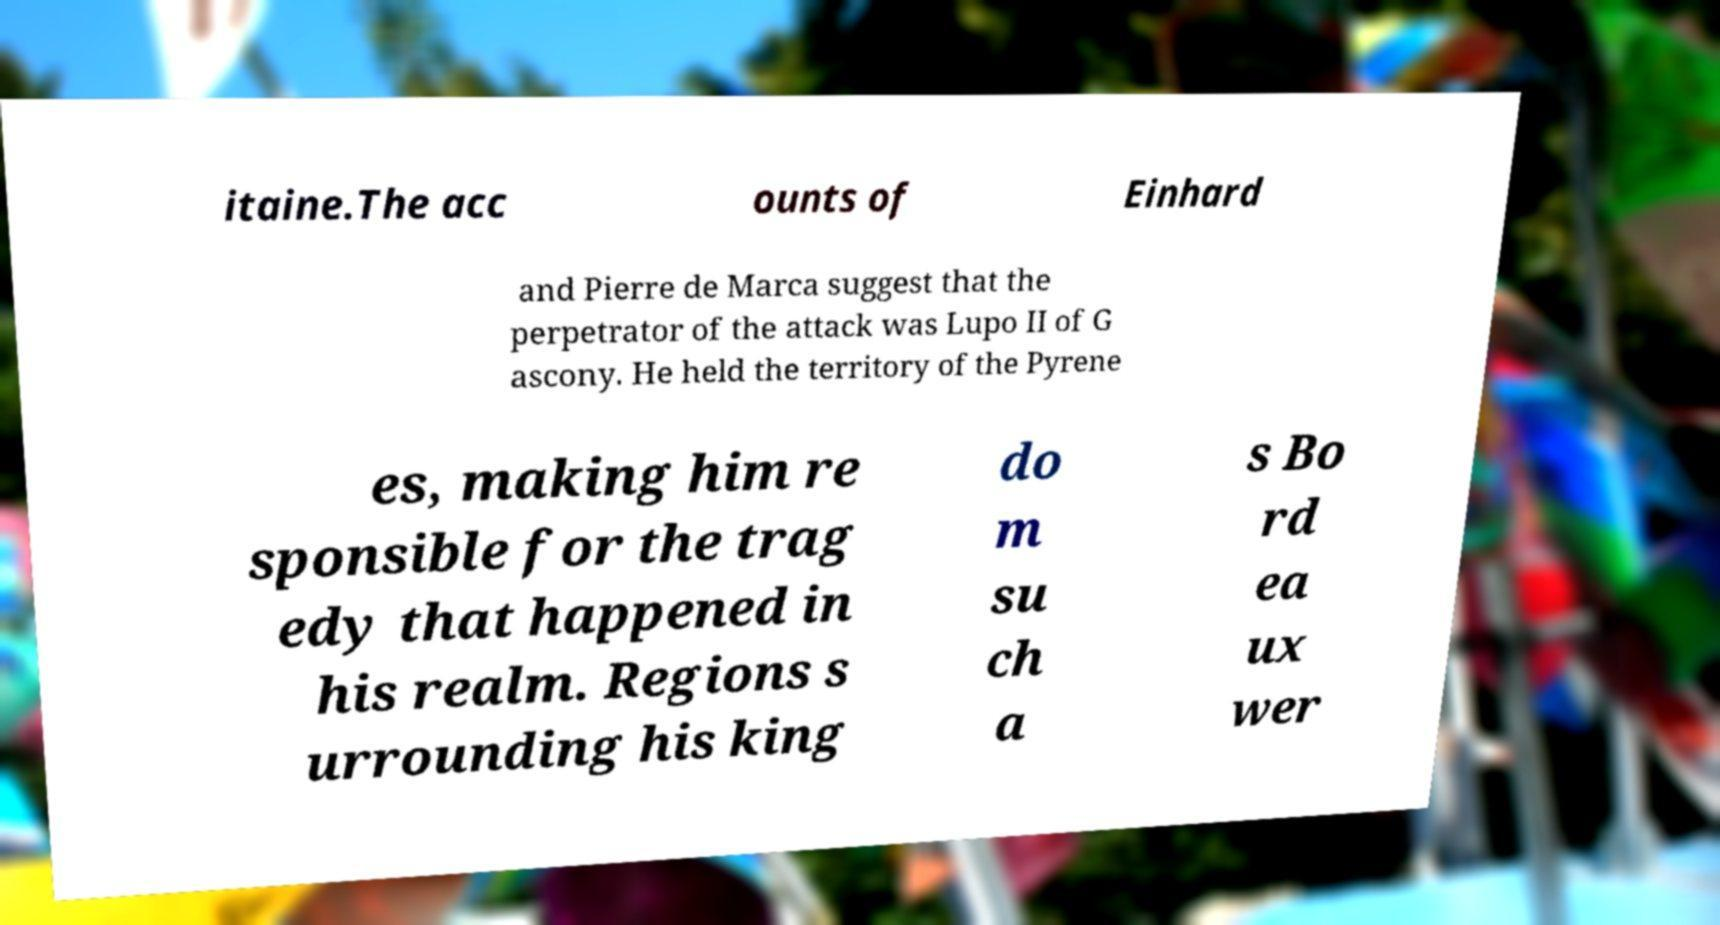What messages or text are displayed in this image? I need them in a readable, typed format. itaine.The acc ounts of Einhard and Pierre de Marca suggest that the perpetrator of the attack was Lupo II of G ascony. He held the territory of the Pyrene es, making him re sponsible for the trag edy that happened in his realm. Regions s urrounding his king do m su ch a s Bo rd ea ux wer 